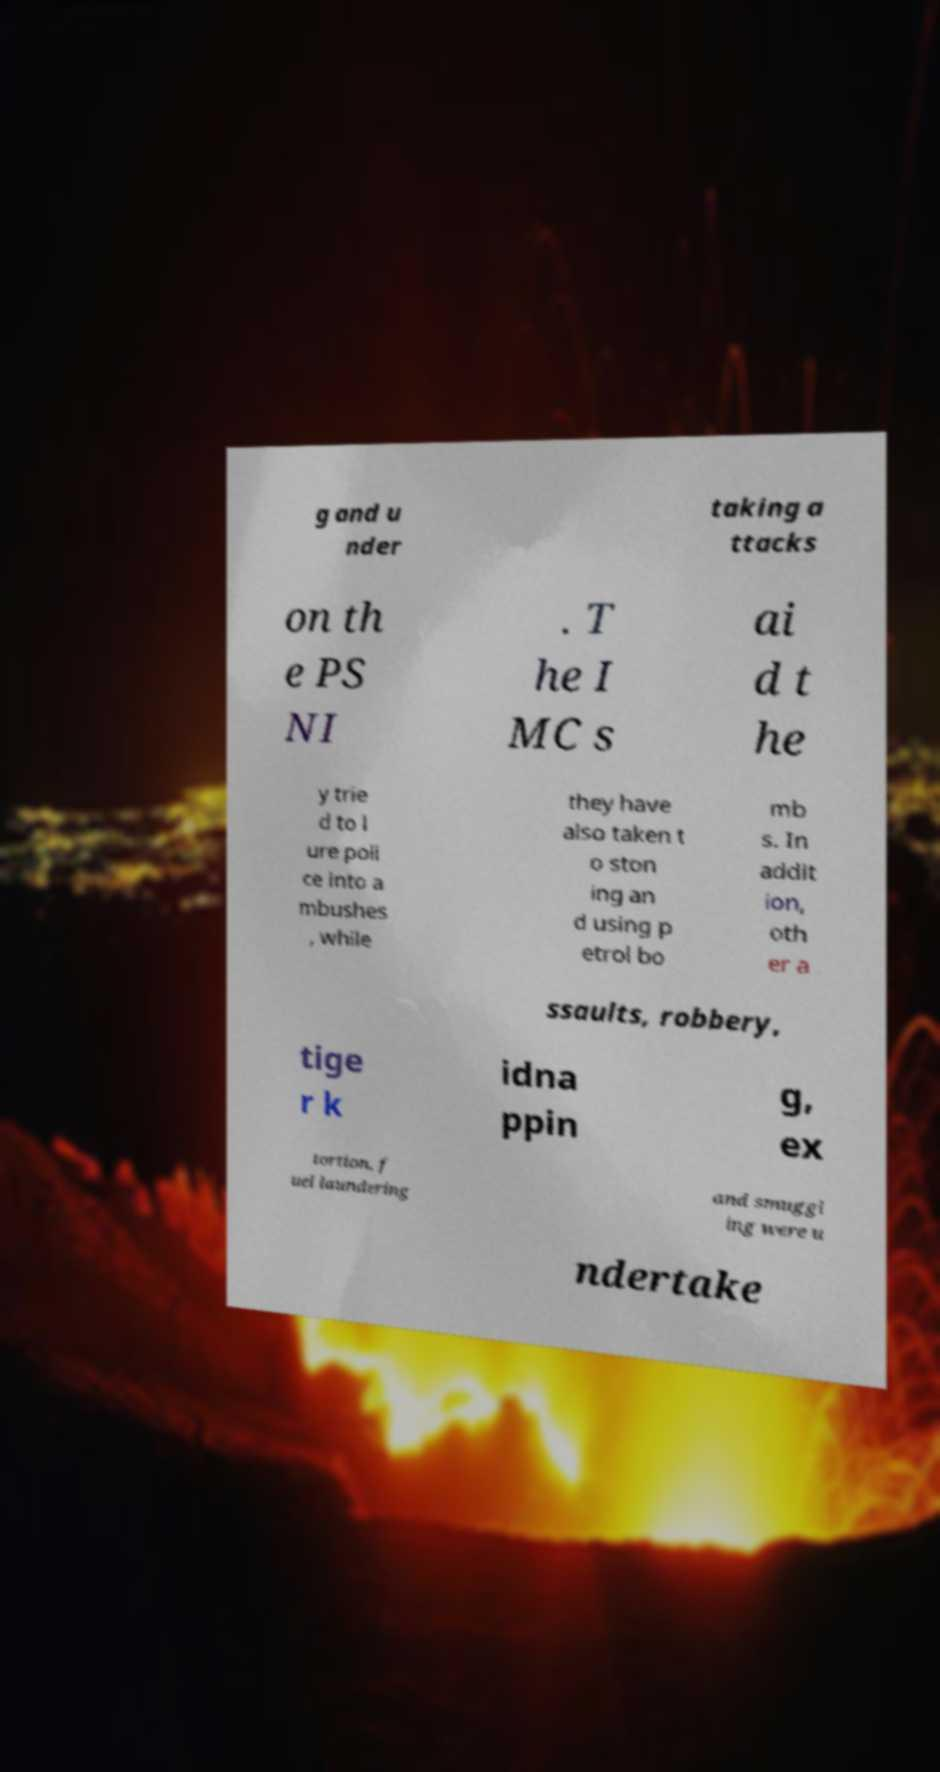Please identify and transcribe the text found in this image. g and u nder taking a ttacks on th e PS NI . T he I MC s ai d t he y trie d to l ure poli ce into a mbushes , while they have also taken t o ston ing an d using p etrol bo mb s. In addit ion, oth er a ssaults, robbery, tige r k idna ppin g, ex tortion, f uel laundering and smuggl ing were u ndertake 